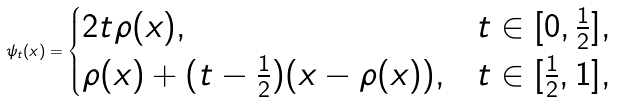Convert formula to latex. <formula><loc_0><loc_0><loc_500><loc_500>\psi _ { t } ( x ) = \begin{cases} 2 t \rho ( x ) , & t \in [ 0 , \frac { 1 } { 2 } ] , \\ \rho ( x ) + ( t - \frac { 1 } { 2 } ) ( x - \rho ( x ) ) , & t \in [ \frac { 1 } { 2 } , 1 ] , \end{cases}</formula> 